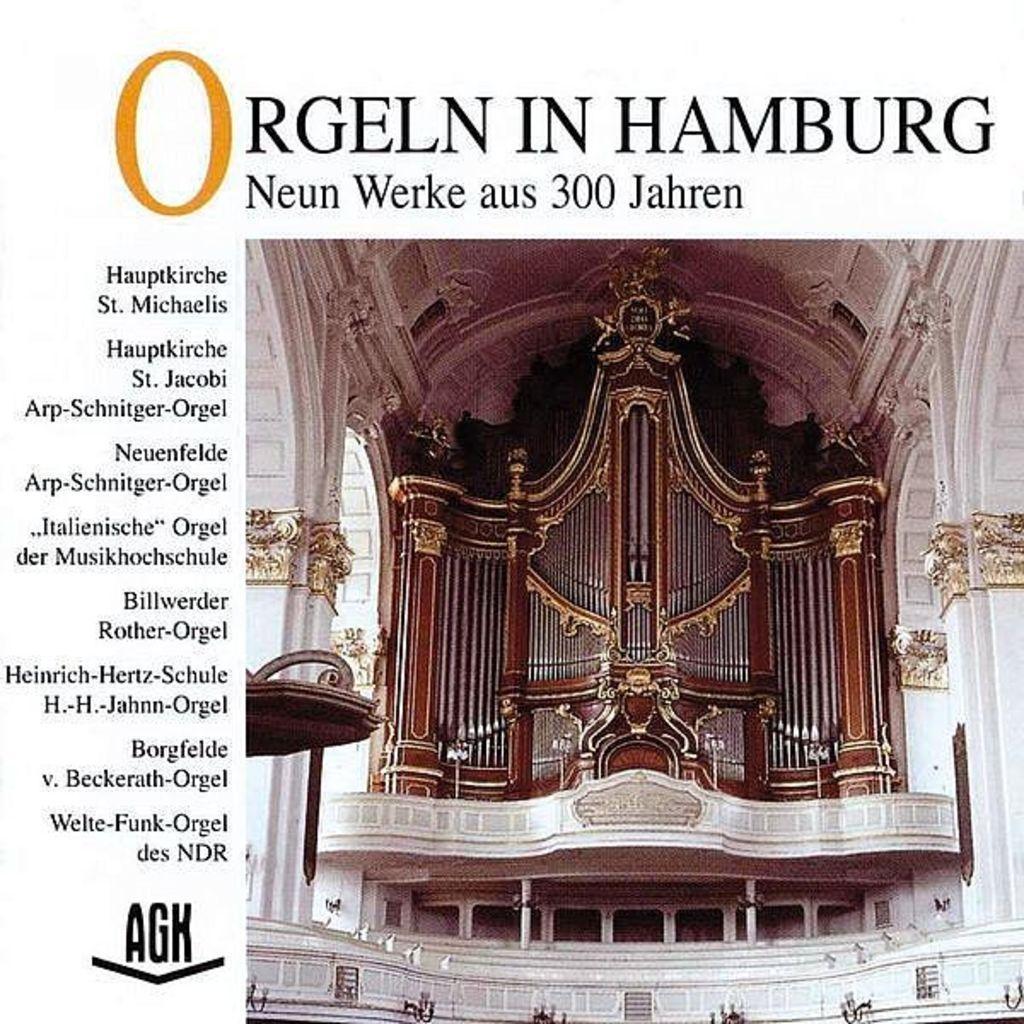In one or two sentences, can you explain what this image depicts? In this image we can see picture of a building with pillars and some text on it. 